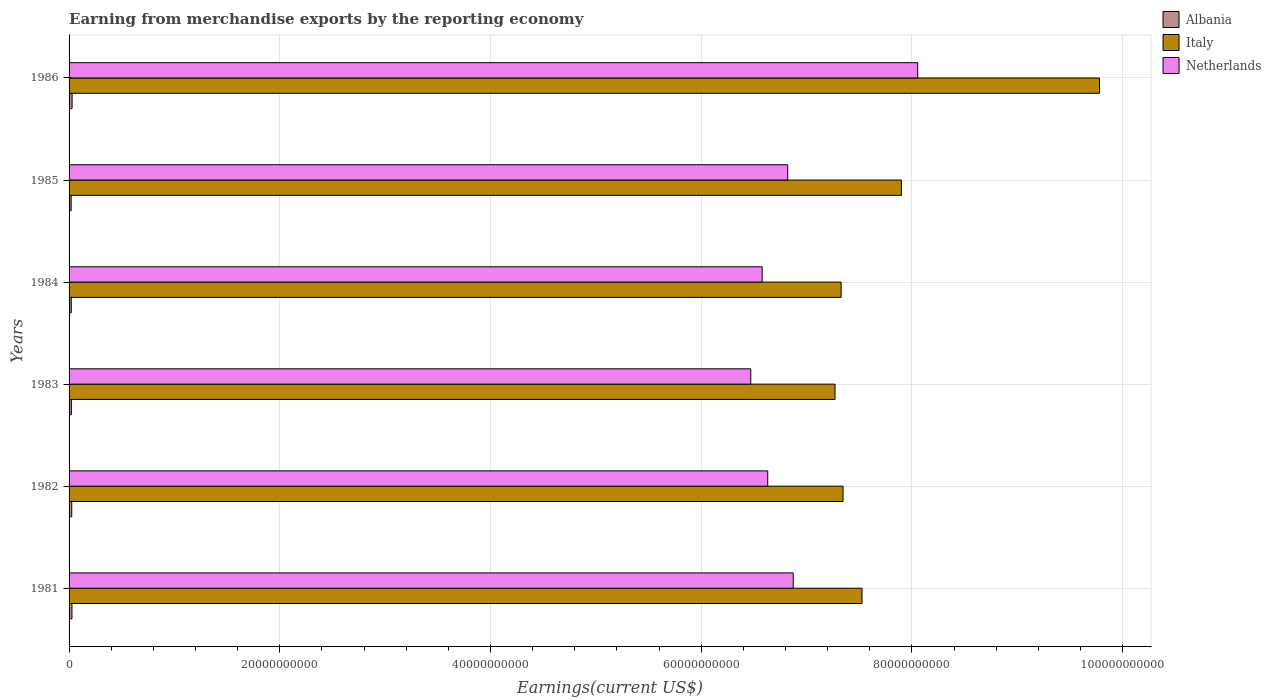How many different coloured bars are there?
Your answer should be compact. 3. Are the number of bars per tick equal to the number of legend labels?
Make the answer very short. Yes. How many bars are there on the 3rd tick from the top?
Offer a very short reply. 3. How many bars are there on the 4th tick from the bottom?
Provide a short and direct response. 3. What is the label of the 5th group of bars from the top?
Your response must be concise. 1982. What is the amount earned from merchandise exports in Italy in 1986?
Give a very brief answer. 9.78e+1. Across all years, what is the maximum amount earned from merchandise exports in Albania?
Ensure brevity in your answer.  2.86e+08. Across all years, what is the minimum amount earned from merchandise exports in Netherlands?
Your answer should be compact. 6.47e+1. In which year was the amount earned from merchandise exports in Italy maximum?
Provide a succinct answer. 1986. In which year was the amount earned from merchandise exports in Albania minimum?
Your answer should be very brief. 1985. What is the total amount earned from merchandise exports in Albania in the graph?
Make the answer very short. 1.44e+09. What is the difference between the amount earned from merchandise exports in Albania in 1981 and that in 1986?
Provide a short and direct response. -1.23e+07. What is the difference between the amount earned from merchandise exports in Italy in 1983 and the amount earned from merchandise exports in Netherlands in 1986?
Offer a terse response. -7.84e+09. What is the average amount earned from merchandise exports in Albania per year?
Offer a terse response. 2.40e+08. In the year 1985, what is the difference between the amount earned from merchandise exports in Italy and amount earned from merchandise exports in Netherlands?
Your answer should be compact. 1.08e+1. What is the ratio of the amount earned from merchandise exports in Netherlands in 1982 to that in 1983?
Your response must be concise. 1.02. Is the amount earned from merchandise exports in Italy in 1983 less than that in 1986?
Offer a very short reply. Yes. Is the difference between the amount earned from merchandise exports in Italy in 1982 and 1986 greater than the difference between the amount earned from merchandise exports in Netherlands in 1982 and 1986?
Offer a terse response. No. What is the difference between the highest and the second highest amount earned from merchandise exports in Netherlands?
Make the answer very short. 1.18e+1. What is the difference between the highest and the lowest amount earned from merchandise exports in Albania?
Your answer should be very brief. 8.78e+07. What does the 2nd bar from the bottom in 1985 represents?
Your answer should be compact. Italy. Is it the case that in every year, the sum of the amount earned from merchandise exports in Netherlands and amount earned from merchandise exports in Italy is greater than the amount earned from merchandise exports in Albania?
Offer a very short reply. Yes. Are all the bars in the graph horizontal?
Your answer should be very brief. Yes. How many years are there in the graph?
Provide a short and direct response. 6. What is the difference between two consecutive major ticks on the X-axis?
Your response must be concise. 2.00e+1. Does the graph contain any zero values?
Offer a very short reply. No. Does the graph contain grids?
Your answer should be very brief. Yes. How many legend labels are there?
Give a very brief answer. 3. How are the legend labels stacked?
Provide a succinct answer. Vertical. What is the title of the graph?
Your response must be concise. Earning from merchandise exports by the reporting economy. Does "Central African Republic" appear as one of the legend labels in the graph?
Make the answer very short. No. What is the label or title of the X-axis?
Ensure brevity in your answer.  Earnings(current US$). What is the label or title of the Y-axis?
Ensure brevity in your answer.  Years. What is the Earnings(current US$) in Albania in 1981?
Make the answer very short. 2.74e+08. What is the Earnings(current US$) in Italy in 1981?
Offer a very short reply. 7.53e+1. What is the Earnings(current US$) of Netherlands in 1981?
Provide a succinct answer. 6.87e+1. What is the Earnings(current US$) in Albania in 1982?
Provide a short and direct response. 2.54e+08. What is the Earnings(current US$) of Italy in 1982?
Give a very brief answer. 7.35e+1. What is the Earnings(current US$) in Netherlands in 1982?
Your answer should be very brief. 6.63e+1. What is the Earnings(current US$) of Albania in 1983?
Give a very brief answer. 2.18e+08. What is the Earnings(current US$) in Italy in 1983?
Your answer should be compact. 7.27e+1. What is the Earnings(current US$) in Netherlands in 1983?
Keep it short and to the point. 6.47e+1. What is the Earnings(current US$) in Albania in 1984?
Provide a succinct answer. 2.10e+08. What is the Earnings(current US$) of Italy in 1984?
Keep it short and to the point. 7.33e+1. What is the Earnings(current US$) in Netherlands in 1984?
Keep it short and to the point. 6.58e+1. What is the Earnings(current US$) in Albania in 1985?
Ensure brevity in your answer.  1.98e+08. What is the Earnings(current US$) of Italy in 1985?
Offer a very short reply. 7.90e+1. What is the Earnings(current US$) in Netherlands in 1985?
Your answer should be very brief. 6.82e+1. What is the Earnings(current US$) in Albania in 1986?
Make the answer very short. 2.86e+08. What is the Earnings(current US$) of Italy in 1986?
Offer a very short reply. 9.78e+1. What is the Earnings(current US$) of Netherlands in 1986?
Offer a terse response. 8.05e+1. Across all years, what is the maximum Earnings(current US$) of Albania?
Provide a short and direct response. 2.86e+08. Across all years, what is the maximum Earnings(current US$) of Italy?
Provide a succinct answer. 9.78e+1. Across all years, what is the maximum Earnings(current US$) in Netherlands?
Make the answer very short. 8.05e+1. Across all years, what is the minimum Earnings(current US$) in Albania?
Give a very brief answer. 1.98e+08. Across all years, what is the minimum Earnings(current US$) of Italy?
Provide a short and direct response. 7.27e+1. Across all years, what is the minimum Earnings(current US$) in Netherlands?
Your response must be concise. 6.47e+1. What is the total Earnings(current US$) of Albania in the graph?
Ensure brevity in your answer.  1.44e+09. What is the total Earnings(current US$) in Italy in the graph?
Give a very brief answer. 4.72e+11. What is the total Earnings(current US$) in Netherlands in the graph?
Give a very brief answer. 4.14e+11. What is the difference between the Earnings(current US$) in Albania in 1981 and that in 1982?
Provide a succinct answer. 2.01e+07. What is the difference between the Earnings(current US$) in Italy in 1981 and that in 1982?
Your answer should be very brief. 1.80e+09. What is the difference between the Earnings(current US$) of Netherlands in 1981 and that in 1982?
Offer a terse response. 2.42e+09. What is the difference between the Earnings(current US$) of Albania in 1981 and that in 1983?
Your answer should be very brief. 5.62e+07. What is the difference between the Earnings(current US$) in Italy in 1981 and that in 1983?
Your answer should be very brief. 2.56e+09. What is the difference between the Earnings(current US$) of Netherlands in 1981 and that in 1983?
Offer a very short reply. 4.03e+09. What is the difference between the Earnings(current US$) in Albania in 1981 and that in 1984?
Offer a terse response. 6.33e+07. What is the difference between the Earnings(current US$) of Italy in 1981 and that in 1984?
Provide a short and direct response. 1.98e+09. What is the difference between the Earnings(current US$) of Netherlands in 1981 and that in 1984?
Offer a terse response. 2.95e+09. What is the difference between the Earnings(current US$) of Albania in 1981 and that in 1985?
Ensure brevity in your answer.  7.54e+07. What is the difference between the Earnings(current US$) of Italy in 1981 and that in 1985?
Ensure brevity in your answer.  -3.74e+09. What is the difference between the Earnings(current US$) of Netherlands in 1981 and that in 1985?
Your response must be concise. 5.26e+08. What is the difference between the Earnings(current US$) of Albania in 1981 and that in 1986?
Your answer should be compact. -1.23e+07. What is the difference between the Earnings(current US$) of Italy in 1981 and that in 1986?
Offer a very short reply. -2.25e+1. What is the difference between the Earnings(current US$) of Netherlands in 1981 and that in 1986?
Provide a short and direct response. -1.18e+1. What is the difference between the Earnings(current US$) of Albania in 1982 and that in 1983?
Provide a succinct answer. 3.61e+07. What is the difference between the Earnings(current US$) in Italy in 1982 and that in 1983?
Offer a terse response. 7.60e+08. What is the difference between the Earnings(current US$) of Netherlands in 1982 and that in 1983?
Your answer should be compact. 1.61e+09. What is the difference between the Earnings(current US$) in Albania in 1982 and that in 1984?
Make the answer very short. 4.32e+07. What is the difference between the Earnings(current US$) of Italy in 1982 and that in 1984?
Ensure brevity in your answer.  1.81e+08. What is the difference between the Earnings(current US$) in Netherlands in 1982 and that in 1984?
Make the answer very short. 5.31e+08. What is the difference between the Earnings(current US$) of Albania in 1982 and that in 1985?
Offer a very short reply. 5.53e+07. What is the difference between the Earnings(current US$) in Italy in 1982 and that in 1985?
Ensure brevity in your answer.  -5.54e+09. What is the difference between the Earnings(current US$) of Netherlands in 1982 and that in 1985?
Offer a terse response. -1.89e+09. What is the difference between the Earnings(current US$) of Albania in 1982 and that in 1986?
Offer a very short reply. -3.24e+07. What is the difference between the Earnings(current US$) in Italy in 1982 and that in 1986?
Your response must be concise. -2.43e+1. What is the difference between the Earnings(current US$) in Netherlands in 1982 and that in 1986?
Offer a very short reply. -1.42e+1. What is the difference between the Earnings(current US$) in Albania in 1983 and that in 1984?
Your answer should be very brief. 7.11e+06. What is the difference between the Earnings(current US$) in Italy in 1983 and that in 1984?
Offer a very short reply. -5.79e+08. What is the difference between the Earnings(current US$) in Netherlands in 1983 and that in 1984?
Ensure brevity in your answer.  -1.08e+09. What is the difference between the Earnings(current US$) of Albania in 1983 and that in 1985?
Give a very brief answer. 1.92e+07. What is the difference between the Earnings(current US$) in Italy in 1983 and that in 1985?
Ensure brevity in your answer.  -6.30e+09. What is the difference between the Earnings(current US$) in Netherlands in 1983 and that in 1985?
Provide a short and direct response. -3.50e+09. What is the difference between the Earnings(current US$) in Albania in 1983 and that in 1986?
Your response must be concise. -6.86e+07. What is the difference between the Earnings(current US$) of Italy in 1983 and that in 1986?
Your response must be concise. -2.51e+1. What is the difference between the Earnings(current US$) in Netherlands in 1983 and that in 1986?
Offer a terse response. -1.58e+1. What is the difference between the Earnings(current US$) in Albania in 1984 and that in 1985?
Offer a terse response. 1.21e+07. What is the difference between the Earnings(current US$) of Italy in 1984 and that in 1985?
Your answer should be very brief. -5.72e+09. What is the difference between the Earnings(current US$) of Netherlands in 1984 and that in 1985?
Make the answer very short. -2.42e+09. What is the difference between the Earnings(current US$) of Albania in 1984 and that in 1986?
Offer a very short reply. -7.57e+07. What is the difference between the Earnings(current US$) of Italy in 1984 and that in 1986?
Your response must be concise. -2.45e+1. What is the difference between the Earnings(current US$) in Netherlands in 1984 and that in 1986?
Offer a very short reply. -1.48e+1. What is the difference between the Earnings(current US$) in Albania in 1985 and that in 1986?
Your answer should be compact. -8.78e+07. What is the difference between the Earnings(current US$) in Italy in 1985 and that in 1986?
Provide a succinct answer. -1.88e+1. What is the difference between the Earnings(current US$) in Netherlands in 1985 and that in 1986?
Your response must be concise. -1.23e+1. What is the difference between the Earnings(current US$) in Albania in 1981 and the Earnings(current US$) in Italy in 1982?
Your answer should be compact. -7.32e+1. What is the difference between the Earnings(current US$) in Albania in 1981 and the Earnings(current US$) in Netherlands in 1982?
Keep it short and to the point. -6.60e+1. What is the difference between the Earnings(current US$) of Italy in 1981 and the Earnings(current US$) of Netherlands in 1982?
Provide a short and direct response. 8.95e+09. What is the difference between the Earnings(current US$) in Albania in 1981 and the Earnings(current US$) in Italy in 1983?
Give a very brief answer. -7.24e+1. What is the difference between the Earnings(current US$) in Albania in 1981 and the Earnings(current US$) in Netherlands in 1983?
Offer a very short reply. -6.44e+1. What is the difference between the Earnings(current US$) of Italy in 1981 and the Earnings(current US$) of Netherlands in 1983?
Give a very brief answer. 1.06e+1. What is the difference between the Earnings(current US$) in Albania in 1981 and the Earnings(current US$) in Italy in 1984?
Your answer should be very brief. -7.30e+1. What is the difference between the Earnings(current US$) in Albania in 1981 and the Earnings(current US$) in Netherlands in 1984?
Offer a very short reply. -6.55e+1. What is the difference between the Earnings(current US$) in Italy in 1981 and the Earnings(current US$) in Netherlands in 1984?
Your answer should be compact. 9.48e+09. What is the difference between the Earnings(current US$) of Albania in 1981 and the Earnings(current US$) of Italy in 1985?
Give a very brief answer. -7.87e+1. What is the difference between the Earnings(current US$) in Albania in 1981 and the Earnings(current US$) in Netherlands in 1985?
Give a very brief answer. -6.79e+1. What is the difference between the Earnings(current US$) of Italy in 1981 and the Earnings(current US$) of Netherlands in 1985?
Provide a succinct answer. 7.05e+09. What is the difference between the Earnings(current US$) of Albania in 1981 and the Earnings(current US$) of Italy in 1986?
Your response must be concise. -9.75e+1. What is the difference between the Earnings(current US$) of Albania in 1981 and the Earnings(current US$) of Netherlands in 1986?
Keep it short and to the point. -8.03e+1. What is the difference between the Earnings(current US$) in Italy in 1981 and the Earnings(current US$) in Netherlands in 1986?
Ensure brevity in your answer.  -5.28e+09. What is the difference between the Earnings(current US$) of Albania in 1982 and the Earnings(current US$) of Italy in 1983?
Your response must be concise. -7.24e+1. What is the difference between the Earnings(current US$) of Albania in 1982 and the Earnings(current US$) of Netherlands in 1983?
Your answer should be very brief. -6.45e+1. What is the difference between the Earnings(current US$) in Italy in 1982 and the Earnings(current US$) in Netherlands in 1983?
Ensure brevity in your answer.  8.76e+09. What is the difference between the Earnings(current US$) in Albania in 1982 and the Earnings(current US$) in Italy in 1984?
Offer a terse response. -7.30e+1. What is the difference between the Earnings(current US$) in Albania in 1982 and the Earnings(current US$) in Netherlands in 1984?
Your response must be concise. -6.55e+1. What is the difference between the Earnings(current US$) in Italy in 1982 and the Earnings(current US$) in Netherlands in 1984?
Your answer should be very brief. 7.68e+09. What is the difference between the Earnings(current US$) in Albania in 1982 and the Earnings(current US$) in Italy in 1985?
Give a very brief answer. -7.87e+1. What is the difference between the Earnings(current US$) of Albania in 1982 and the Earnings(current US$) of Netherlands in 1985?
Your answer should be very brief. -6.80e+1. What is the difference between the Earnings(current US$) in Italy in 1982 and the Earnings(current US$) in Netherlands in 1985?
Your answer should be very brief. 5.25e+09. What is the difference between the Earnings(current US$) in Albania in 1982 and the Earnings(current US$) in Italy in 1986?
Give a very brief answer. -9.76e+1. What is the difference between the Earnings(current US$) in Albania in 1982 and the Earnings(current US$) in Netherlands in 1986?
Give a very brief answer. -8.03e+1. What is the difference between the Earnings(current US$) of Italy in 1982 and the Earnings(current US$) of Netherlands in 1986?
Provide a succinct answer. -7.08e+09. What is the difference between the Earnings(current US$) in Albania in 1983 and the Earnings(current US$) in Italy in 1984?
Your response must be concise. -7.31e+1. What is the difference between the Earnings(current US$) in Albania in 1983 and the Earnings(current US$) in Netherlands in 1984?
Provide a succinct answer. -6.56e+1. What is the difference between the Earnings(current US$) of Italy in 1983 and the Earnings(current US$) of Netherlands in 1984?
Provide a short and direct response. 6.92e+09. What is the difference between the Earnings(current US$) in Albania in 1983 and the Earnings(current US$) in Italy in 1985?
Your answer should be very brief. -7.88e+1. What is the difference between the Earnings(current US$) of Albania in 1983 and the Earnings(current US$) of Netherlands in 1985?
Offer a terse response. -6.80e+1. What is the difference between the Earnings(current US$) of Italy in 1983 and the Earnings(current US$) of Netherlands in 1985?
Your answer should be compact. 4.49e+09. What is the difference between the Earnings(current US$) of Albania in 1983 and the Earnings(current US$) of Italy in 1986?
Make the answer very short. -9.76e+1. What is the difference between the Earnings(current US$) in Albania in 1983 and the Earnings(current US$) in Netherlands in 1986?
Provide a short and direct response. -8.03e+1. What is the difference between the Earnings(current US$) of Italy in 1983 and the Earnings(current US$) of Netherlands in 1986?
Give a very brief answer. -7.84e+09. What is the difference between the Earnings(current US$) in Albania in 1984 and the Earnings(current US$) in Italy in 1985?
Keep it short and to the point. -7.88e+1. What is the difference between the Earnings(current US$) of Albania in 1984 and the Earnings(current US$) of Netherlands in 1985?
Provide a short and direct response. -6.80e+1. What is the difference between the Earnings(current US$) of Italy in 1984 and the Earnings(current US$) of Netherlands in 1985?
Your answer should be compact. 5.07e+09. What is the difference between the Earnings(current US$) in Albania in 1984 and the Earnings(current US$) in Italy in 1986?
Your answer should be compact. -9.76e+1. What is the difference between the Earnings(current US$) of Albania in 1984 and the Earnings(current US$) of Netherlands in 1986?
Your response must be concise. -8.03e+1. What is the difference between the Earnings(current US$) of Italy in 1984 and the Earnings(current US$) of Netherlands in 1986?
Offer a terse response. -7.26e+09. What is the difference between the Earnings(current US$) in Albania in 1985 and the Earnings(current US$) in Italy in 1986?
Offer a very short reply. -9.76e+1. What is the difference between the Earnings(current US$) of Albania in 1985 and the Earnings(current US$) of Netherlands in 1986?
Your response must be concise. -8.03e+1. What is the difference between the Earnings(current US$) of Italy in 1985 and the Earnings(current US$) of Netherlands in 1986?
Provide a succinct answer. -1.55e+09. What is the average Earnings(current US$) of Albania per year?
Provide a short and direct response. 2.40e+08. What is the average Earnings(current US$) of Italy per year?
Offer a very short reply. 7.86e+1. What is the average Earnings(current US$) of Netherlands per year?
Your answer should be compact. 6.90e+1. In the year 1981, what is the difference between the Earnings(current US$) in Albania and Earnings(current US$) in Italy?
Give a very brief answer. -7.50e+1. In the year 1981, what is the difference between the Earnings(current US$) in Albania and Earnings(current US$) in Netherlands?
Give a very brief answer. -6.85e+1. In the year 1981, what is the difference between the Earnings(current US$) in Italy and Earnings(current US$) in Netherlands?
Your response must be concise. 6.53e+09. In the year 1982, what is the difference between the Earnings(current US$) in Albania and Earnings(current US$) in Italy?
Provide a succinct answer. -7.32e+1. In the year 1982, what is the difference between the Earnings(current US$) in Albania and Earnings(current US$) in Netherlands?
Your response must be concise. -6.61e+1. In the year 1982, what is the difference between the Earnings(current US$) of Italy and Earnings(current US$) of Netherlands?
Provide a short and direct response. 7.15e+09. In the year 1983, what is the difference between the Earnings(current US$) in Albania and Earnings(current US$) in Italy?
Ensure brevity in your answer.  -7.25e+1. In the year 1983, what is the difference between the Earnings(current US$) of Albania and Earnings(current US$) of Netherlands?
Your response must be concise. -6.45e+1. In the year 1983, what is the difference between the Earnings(current US$) in Italy and Earnings(current US$) in Netherlands?
Provide a short and direct response. 8.00e+09. In the year 1984, what is the difference between the Earnings(current US$) in Albania and Earnings(current US$) in Italy?
Keep it short and to the point. -7.31e+1. In the year 1984, what is the difference between the Earnings(current US$) of Albania and Earnings(current US$) of Netherlands?
Ensure brevity in your answer.  -6.56e+1. In the year 1984, what is the difference between the Earnings(current US$) of Italy and Earnings(current US$) of Netherlands?
Your response must be concise. 7.50e+09. In the year 1985, what is the difference between the Earnings(current US$) of Albania and Earnings(current US$) of Italy?
Your answer should be very brief. -7.88e+1. In the year 1985, what is the difference between the Earnings(current US$) of Albania and Earnings(current US$) of Netherlands?
Your response must be concise. -6.80e+1. In the year 1985, what is the difference between the Earnings(current US$) of Italy and Earnings(current US$) of Netherlands?
Offer a terse response. 1.08e+1. In the year 1986, what is the difference between the Earnings(current US$) in Albania and Earnings(current US$) in Italy?
Offer a terse response. -9.75e+1. In the year 1986, what is the difference between the Earnings(current US$) in Albania and Earnings(current US$) in Netherlands?
Ensure brevity in your answer.  -8.03e+1. In the year 1986, what is the difference between the Earnings(current US$) in Italy and Earnings(current US$) in Netherlands?
Your response must be concise. 1.73e+1. What is the ratio of the Earnings(current US$) of Albania in 1981 to that in 1982?
Give a very brief answer. 1.08. What is the ratio of the Earnings(current US$) of Italy in 1981 to that in 1982?
Your answer should be compact. 1.02. What is the ratio of the Earnings(current US$) of Netherlands in 1981 to that in 1982?
Your answer should be very brief. 1.04. What is the ratio of the Earnings(current US$) in Albania in 1981 to that in 1983?
Make the answer very short. 1.26. What is the ratio of the Earnings(current US$) of Italy in 1981 to that in 1983?
Your response must be concise. 1.04. What is the ratio of the Earnings(current US$) in Netherlands in 1981 to that in 1983?
Your answer should be compact. 1.06. What is the ratio of the Earnings(current US$) in Albania in 1981 to that in 1984?
Offer a terse response. 1.3. What is the ratio of the Earnings(current US$) of Italy in 1981 to that in 1984?
Keep it short and to the point. 1.03. What is the ratio of the Earnings(current US$) of Netherlands in 1981 to that in 1984?
Make the answer very short. 1.04. What is the ratio of the Earnings(current US$) of Albania in 1981 to that in 1985?
Offer a very short reply. 1.38. What is the ratio of the Earnings(current US$) in Italy in 1981 to that in 1985?
Your answer should be very brief. 0.95. What is the ratio of the Earnings(current US$) in Netherlands in 1981 to that in 1985?
Provide a succinct answer. 1.01. What is the ratio of the Earnings(current US$) in Albania in 1981 to that in 1986?
Your answer should be compact. 0.96. What is the ratio of the Earnings(current US$) in Italy in 1981 to that in 1986?
Give a very brief answer. 0.77. What is the ratio of the Earnings(current US$) in Netherlands in 1981 to that in 1986?
Your answer should be compact. 0.85. What is the ratio of the Earnings(current US$) of Albania in 1982 to that in 1983?
Offer a terse response. 1.17. What is the ratio of the Earnings(current US$) of Italy in 1982 to that in 1983?
Provide a short and direct response. 1.01. What is the ratio of the Earnings(current US$) in Netherlands in 1982 to that in 1983?
Your answer should be very brief. 1.02. What is the ratio of the Earnings(current US$) in Albania in 1982 to that in 1984?
Your response must be concise. 1.21. What is the ratio of the Earnings(current US$) of Italy in 1982 to that in 1984?
Provide a succinct answer. 1. What is the ratio of the Earnings(current US$) in Albania in 1982 to that in 1985?
Offer a very short reply. 1.28. What is the ratio of the Earnings(current US$) of Italy in 1982 to that in 1985?
Your answer should be compact. 0.93. What is the ratio of the Earnings(current US$) in Netherlands in 1982 to that in 1985?
Provide a succinct answer. 0.97. What is the ratio of the Earnings(current US$) in Albania in 1982 to that in 1986?
Keep it short and to the point. 0.89. What is the ratio of the Earnings(current US$) of Italy in 1982 to that in 1986?
Offer a terse response. 0.75. What is the ratio of the Earnings(current US$) in Netherlands in 1982 to that in 1986?
Provide a succinct answer. 0.82. What is the ratio of the Earnings(current US$) of Albania in 1983 to that in 1984?
Keep it short and to the point. 1.03. What is the ratio of the Earnings(current US$) of Italy in 1983 to that in 1984?
Offer a very short reply. 0.99. What is the ratio of the Earnings(current US$) in Netherlands in 1983 to that in 1984?
Offer a very short reply. 0.98. What is the ratio of the Earnings(current US$) in Albania in 1983 to that in 1985?
Your answer should be compact. 1.1. What is the ratio of the Earnings(current US$) of Italy in 1983 to that in 1985?
Your answer should be compact. 0.92. What is the ratio of the Earnings(current US$) of Netherlands in 1983 to that in 1985?
Keep it short and to the point. 0.95. What is the ratio of the Earnings(current US$) in Albania in 1983 to that in 1986?
Provide a short and direct response. 0.76. What is the ratio of the Earnings(current US$) of Italy in 1983 to that in 1986?
Provide a short and direct response. 0.74. What is the ratio of the Earnings(current US$) of Netherlands in 1983 to that in 1986?
Keep it short and to the point. 0.8. What is the ratio of the Earnings(current US$) in Albania in 1984 to that in 1985?
Keep it short and to the point. 1.06. What is the ratio of the Earnings(current US$) of Italy in 1984 to that in 1985?
Your response must be concise. 0.93. What is the ratio of the Earnings(current US$) of Netherlands in 1984 to that in 1985?
Offer a terse response. 0.96. What is the ratio of the Earnings(current US$) of Albania in 1984 to that in 1986?
Ensure brevity in your answer.  0.74. What is the ratio of the Earnings(current US$) of Italy in 1984 to that in 1986?
Make the answer very short. 0.75. What is the ratio of the Earnings(current US$) of Netherlands in 1984 to that in 1986?
Your response must be concise. 0.82. What is the ratio of the Earnings(current US$) in Albania in 1985 to that in 1986?
Ensure brevity in your answer.  0.69. What is the ratio of the Earnings(current US$) in Italy in 1985 to that in 1986?
Provide a succinct answer. 0.81. What is the ratio of the Earnings(current US$) in Netherlands in 1985 to that in 1986?
Make the answer very short. 0.85. What is the difference between the highest and the second highest Earnings(current US$) of Albania?
Make the answer very short. 1.23e+07. What is the difference between the highest and the second highest Earnings(current US$) of Italy?
Your answer should be very brief. 1.88e+1. What is the difference between the highest and the second highest Earnings(current US$) in Netherlands?
Provide a short and direct response. 1.18e+1. What is the difference between the highest and the lowest Earnings(current US$) in Albania?
Offer a very short reply. 8.78e+07. What is the difference between the highest and the lowest Earnings(current US$) in Italy?
Your response must be concise. 2.51e+1. What is the difference between the highest and the lowest Earnings(current US$) of Netherlands?
Keep it short and to the point. 1.58e+1. 